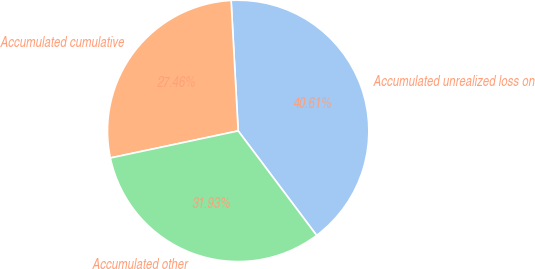<chart> <loc_0><loc_0><loc_500><loc_500><pie_chart><fcel>Accumulated unrealized loss on<fcel>Accumulated cumulative<fcel>Accumulated other<nl><fcel>40.61%<fcel>27.46%<fcel>31.93%<nl></chart> 